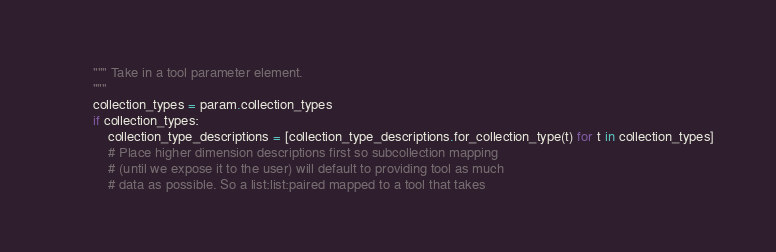<code> <loc_0><loc_0><loc_500><loc_500><_Python_>        """ Take in a tool parameter element.
        """
        collection_types = param.collection_types
        if collection_types:
            collection_type_descriptions = [collection_type_descriptions.for_collection_type(t) for t in collection_types]
            # Place higher dimension descriptions first so subcollection mapping
            # (until we expose it to the user) will default to providing tool as much
            # data as possible. So a list:list:paired mapped to a tool that takes</code> 